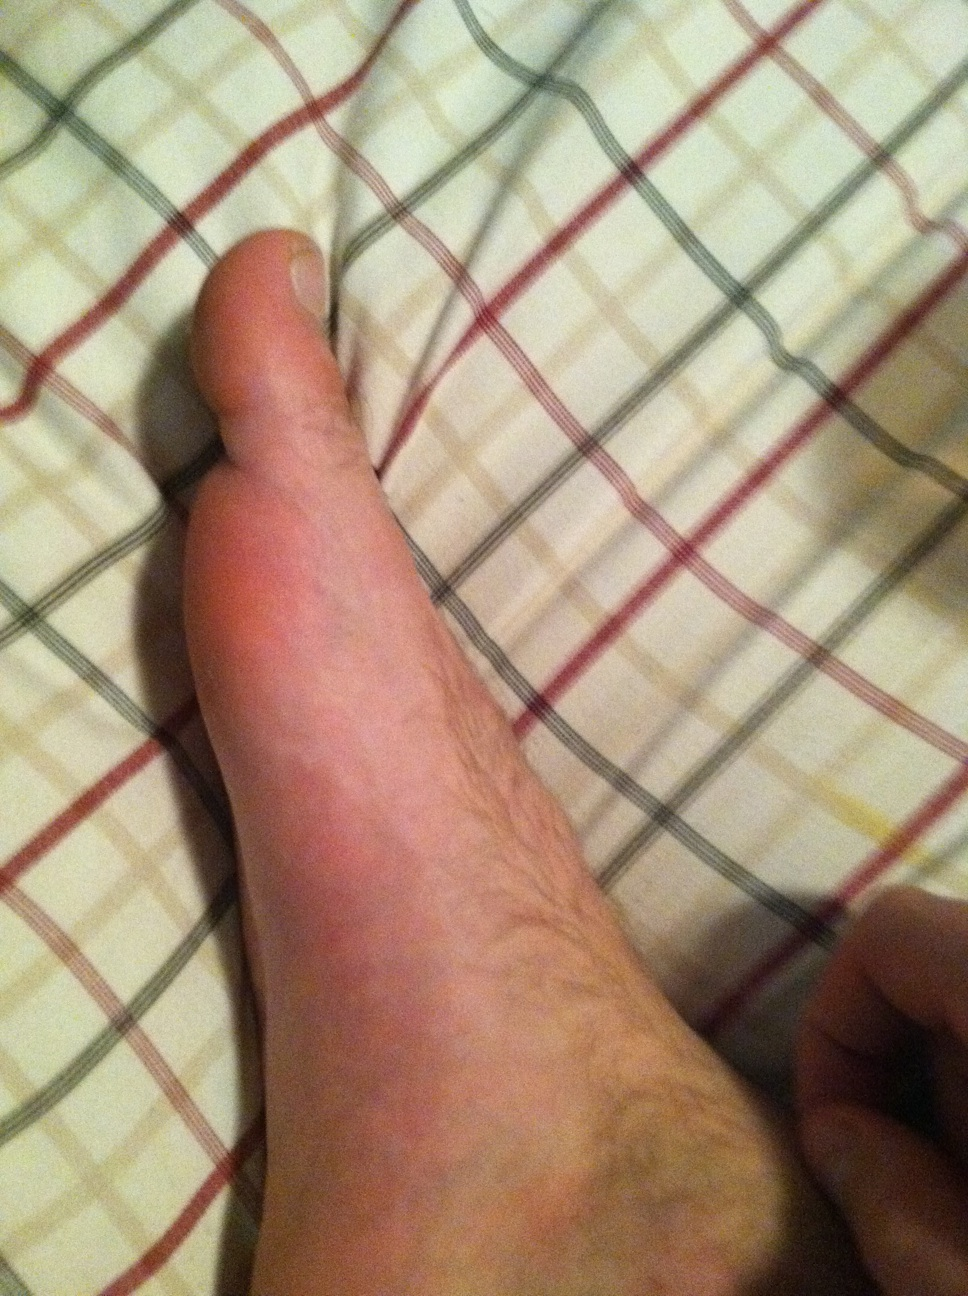What activity might have caused the redness on the arm? The redness on the arm could be caused by various activities. It might be the result of pressure being applied to the skin, which can happen if the arm was resting on a hard or uneven surface for a period of time. Alternatively, it could also be a slight skin reaction, maybe due to fabric or heat exposure. 